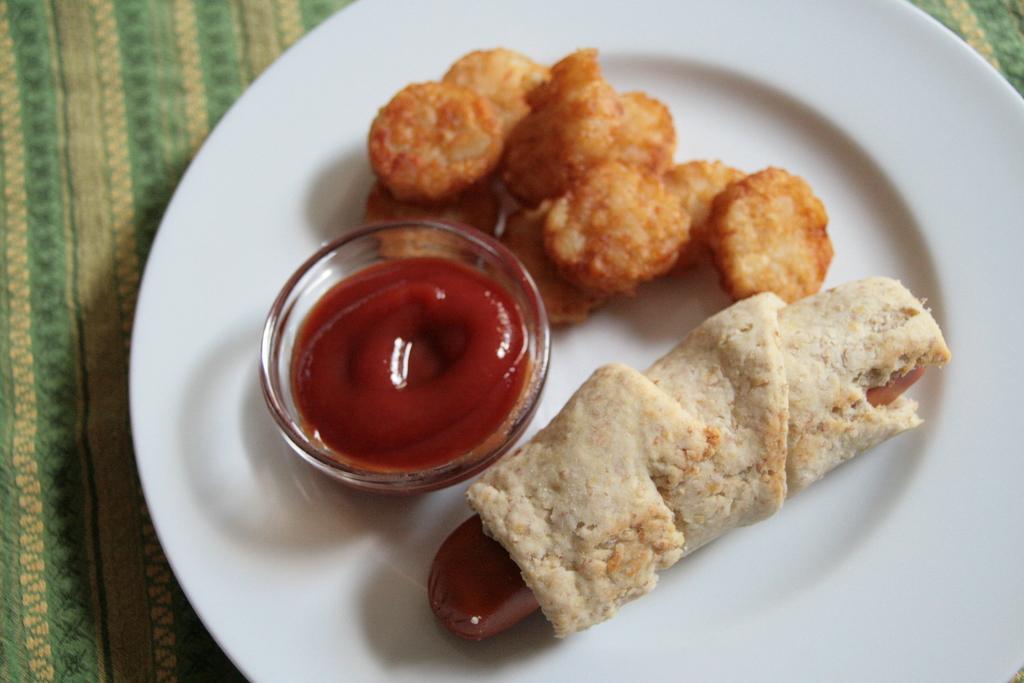Please provide a concise description of this image. In this image I can see food which is in brown, red and cream color in the plate. The plate is in white color and the plate is on the green color cloth. 